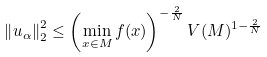Convert formula to latex. <formula><loc_0><loc_0><loc_500><loc_500>\left \| u _ { \alpha } \right \| _ { 2 } ^ { 2 } \leq \left ( \min _ { x \in M } f ( x ) \right ) ^ { - \frac { 2 } { N } } V ( M ) ^ { 1 - \frac { 2 } { N } }</formula> 